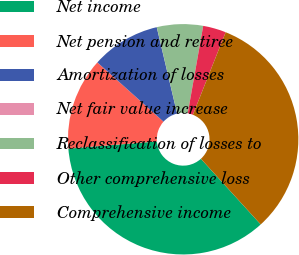Convert chart to OTSL. <chart><loc_0><loc_0><loc_500><loc_500><pie_chart><fcel>Net income<fcel>Net pension and retiree<fcel>Amortization of losses<fcel>Net fair value increase<fcel>Reclassification of losses to<fcel>Other comprehensive loss<fcel>Comprehensive income<nl><fcel>35.46%<fcel>12.92%<fcel>9.69%<fcel>0.01%<fcel>6.46%<fcel>3.23%<fcel>32.23%<nl></chart> 